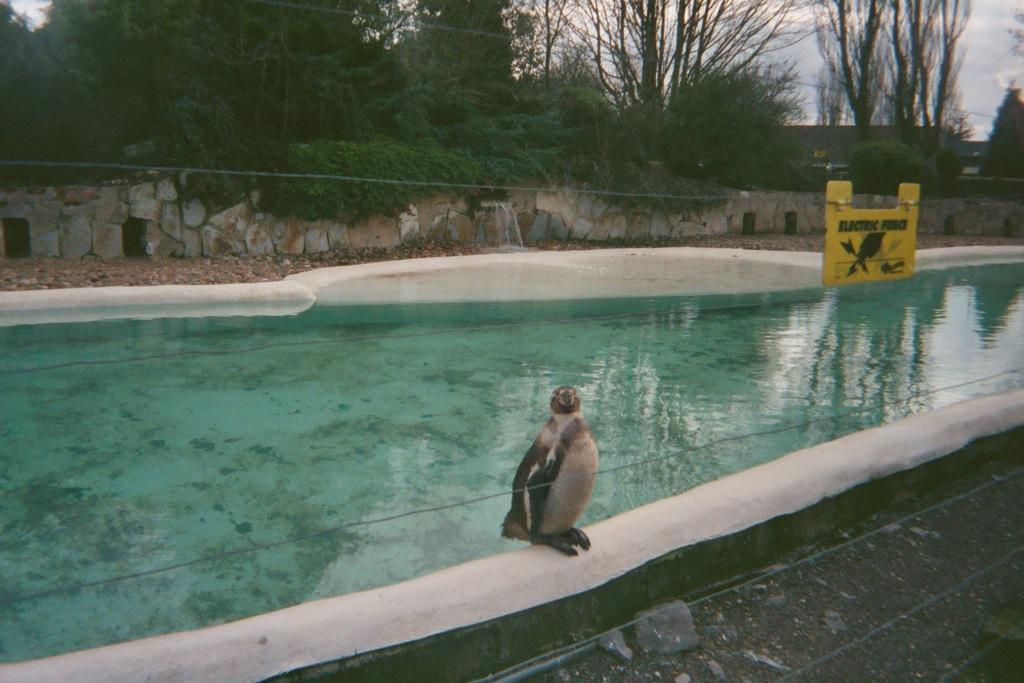In one or two sentences, can you explain what this image depicts? In this picture I can see there is a penguin and there is a pond in the backdrop, there is an electric fence and there are few rocks in the backdrop, trees and the sky is clear. 